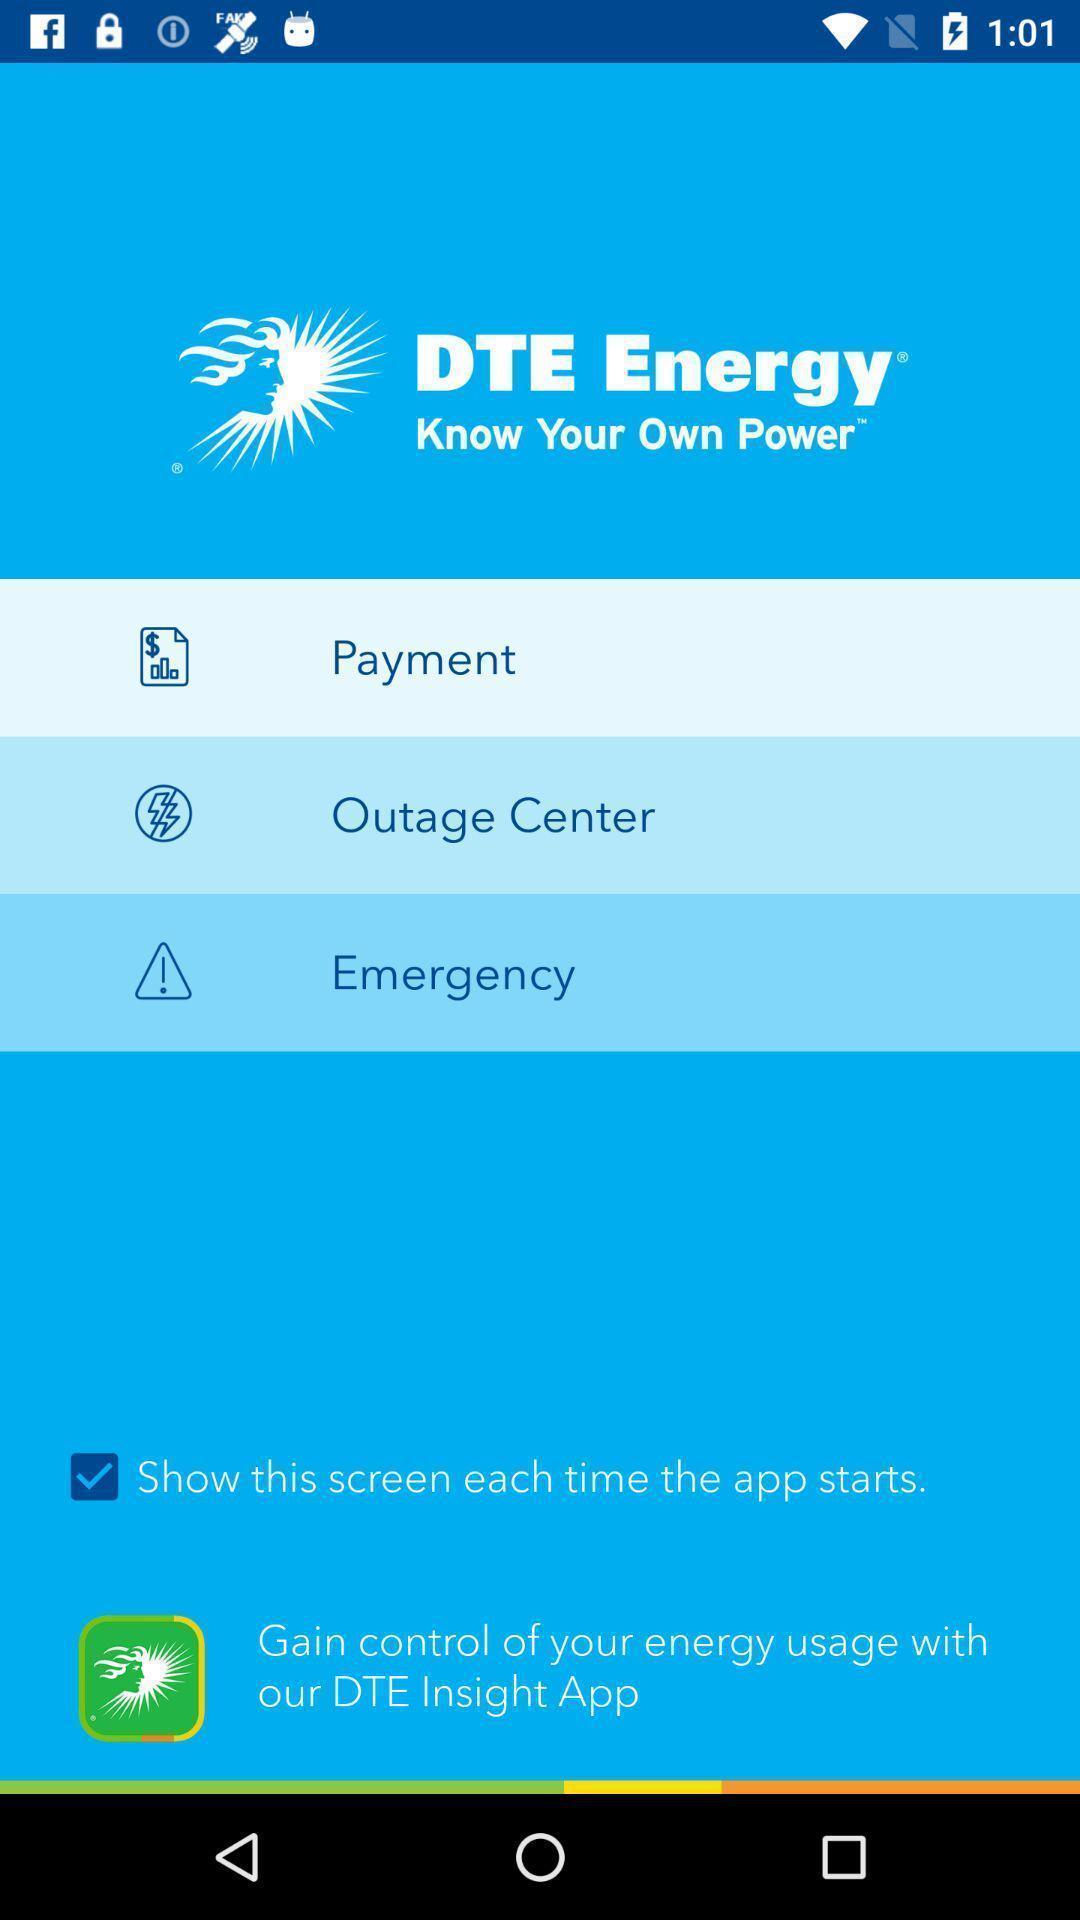Summarize the main components in this picture. Welcome page of a bill payments application. 